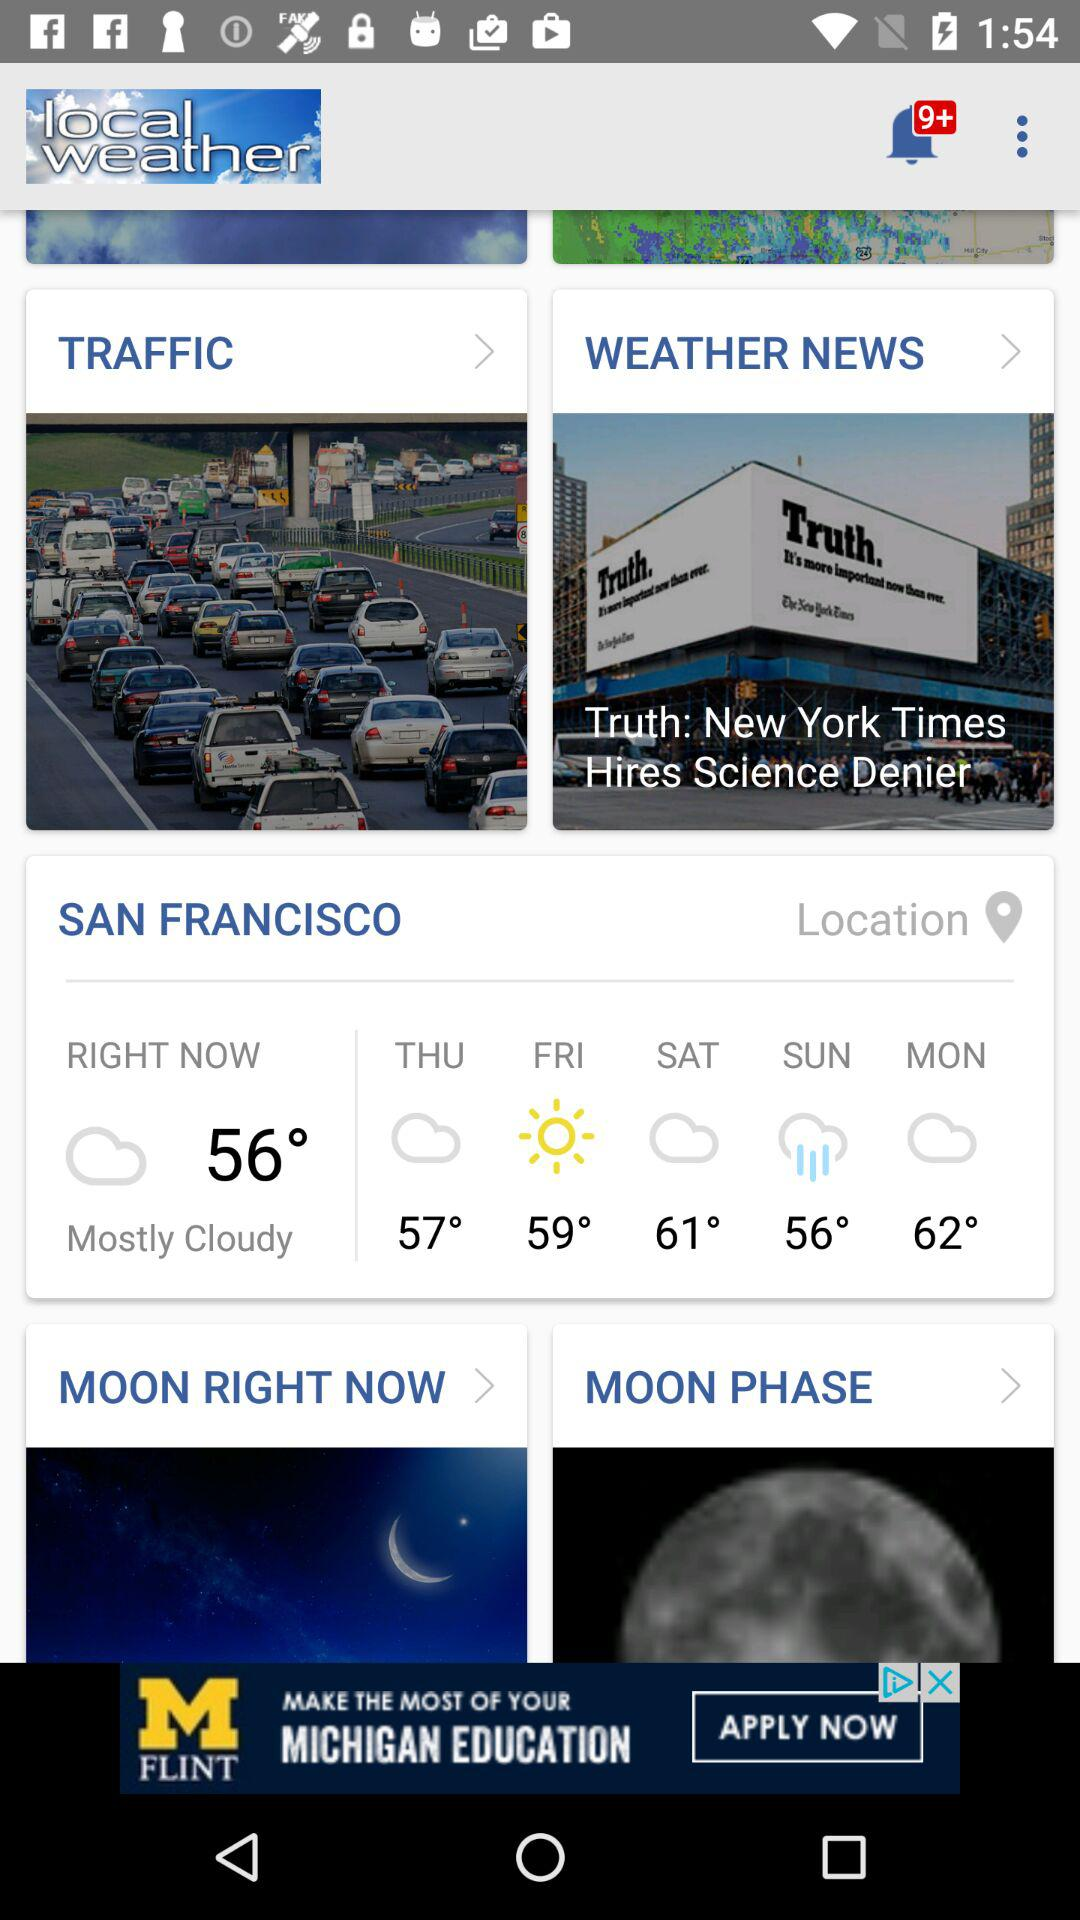What will the temperature be on Monday? The temperature will be 62° on Monday. 